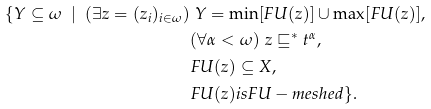<formula> <loc_0><loc_0><loc_500><loc_500>\{ Y \subseteq \omega \ | \ ( \exists z = ( z _ { i } ) _ { i \in \omega } ) & \ Y = \min [ F U ( z ) ] \cup \max [ F U ( z ) ] , \\ & ( \forall \alpha < \omega ) \ z \sqsubseteq ^ { * } t ^ { \alpha } , \\ & F U ( z ) \subseteq X , \\ & F U ( z ) i s F U - m e s h e d \} .</formula> 